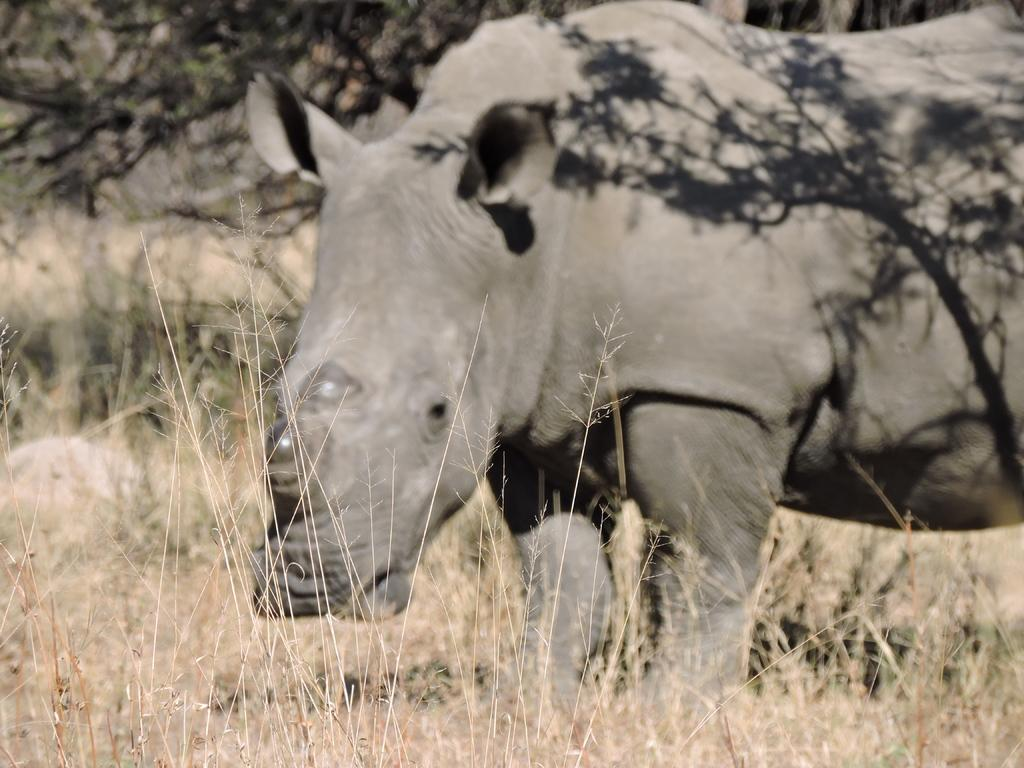What type of vegetation is present in the image? There is dry grass in the image. What other natural elements can be seen in the image? There are trees in the image. What animal is featured in the image? A: There is a hippopotamus in the image. What type of substance is the hippopotamus using to sit on in the image? There is no substance or furniture present in the image; the hippopotamus is standing on dry grass and among trees. 